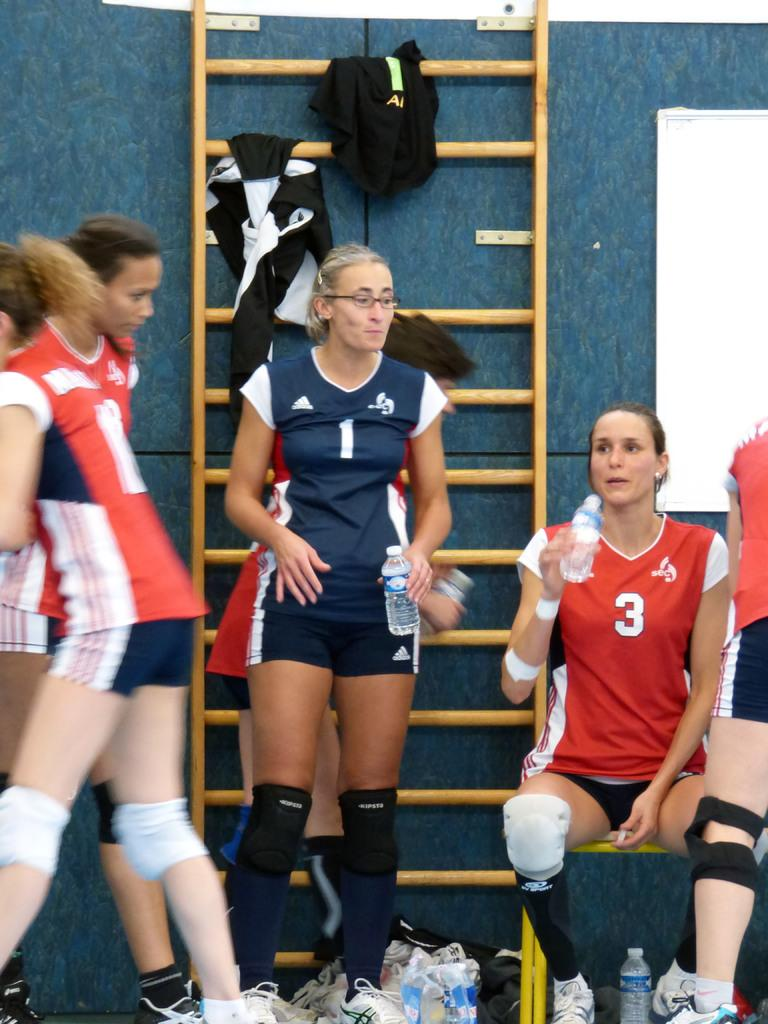<image>
Render a clear and concise summary of the photo. A volleyball player sitting on a bench with the number 3 on her shirt and other players standing around 